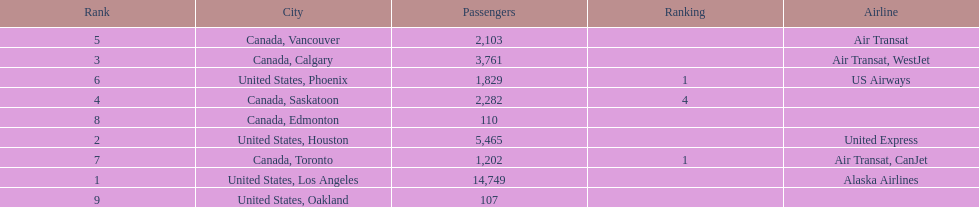What was the number of passengers in phoenix arizona? 1,829. 